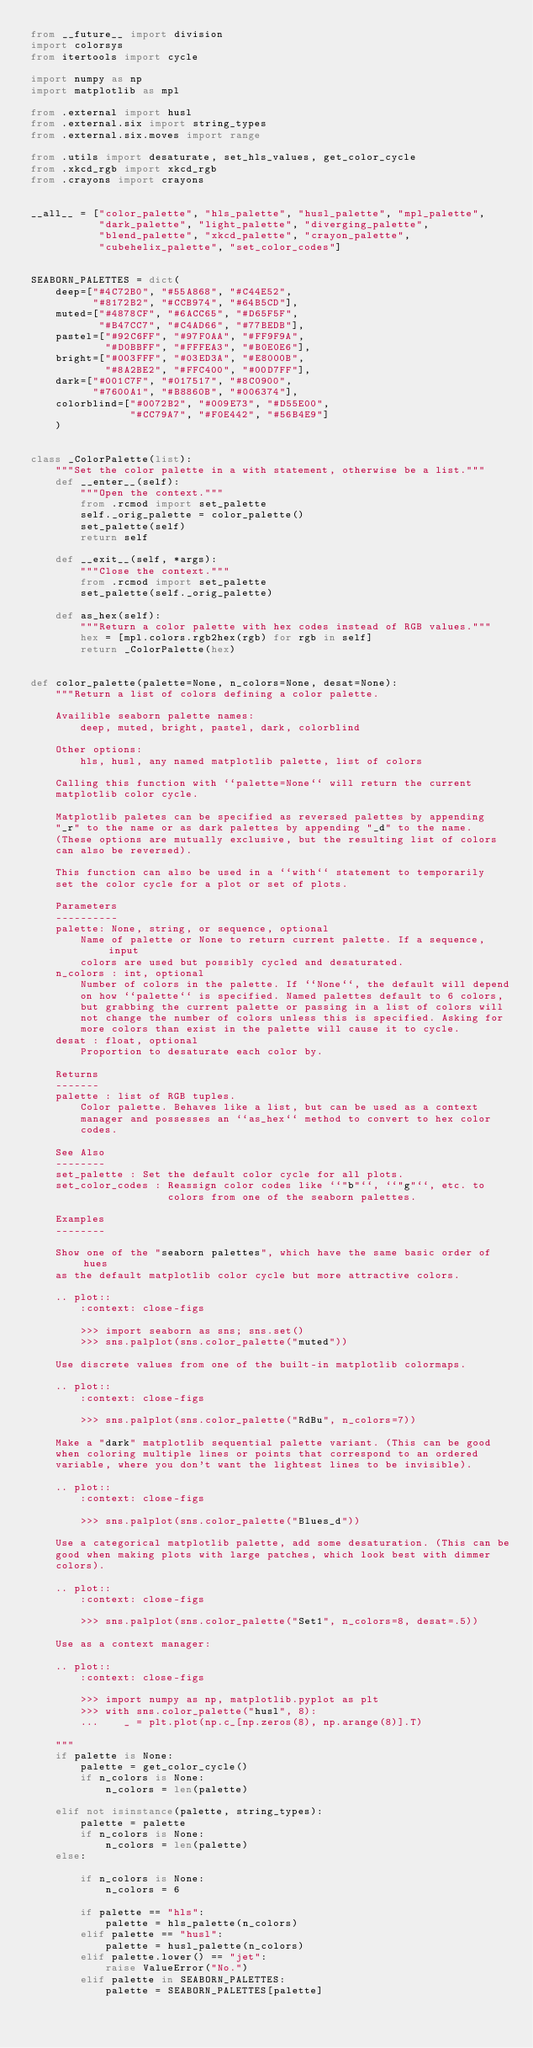Convert code to text. <code><loc_0><loc_0><loc_500><loc_500><_Python_>from __future__ import division
import colorsys
from itertools import cycle

import numpy as np
import matplotlib as mpl

from .external import husl
from .external.six import string_types
from .external.six.moves import range

from .utils import desaturate, set_hls_values, get_color_cycle
from .xkcd_rgb import xkcd_rgb
from .crayons import crayons


__all__ = ["color_palette", "hls_palette", "husl_palette", "mpl_palette",
           "dark_palette", "light_palette", "diverging_palette",
           "blend_palette", "xkcd_palette", "crayon_palette",
           "cubehelix_palette", "set_color_codes"]


SEABORN_PALETTES = dict(
    deep=["#4C72B0", "#55A868", "#C44E52",
          "#8172B2", "#CCB974", "#64B5CD"],
    muted=["#4878CF", "#6ACC65", "#D65F5F",
           "#B47CC7", "#C4AD66", "#77BEDB"],
    pastel=["#92C6FF", "#97F0AA", "#FF9F9A",
            "#D0BBFF", "#FFFEA3", "#B0E0E6"],
    bright=["#003FFF", "#03ED3A", "#E8000B",
            "#8A2BE2", "#FFC400", "#00D7FF"],
    dark=["#001C7F", "#017517", "#8C0900",
          "#7600A1", "#B8860B", "#006374"],
    colorblind=["#0072B2", "#009E73", "#D55E00",
                "#CC79A7", "#F0E442", "#56B4E9"]
    )


class _ColorPalette(list):
    """Set the color palette in a with statement, otherwise be a list."""
    def __enter__(self):
        """Open the context."""
        from .rcmod import set_palette
        self._orig_palette = color_palette()
        set_palette(self)
        return self

    def __exit__(self, *args):
        """Close the context."""
        from .rcmod import set_palette
        set_palette(self._orig_palette)

    def as_hex(self):
        """Return a color palette with hex codes instead of RGB values."""
        hex = [mpl.colors.rgb2hex(rgb) for rgb in self]
        return _ColorPalette(hex)


def color_palette(palette=None, n_colors=None, desat=None):
    """Return a list of colors defining a color palette.

    Availible seaborn palette names:
        deep, muted, bright, pastel, dark, colorblind

    Other options:
        hls, husl, any named matplotlib palette, list of colors

    Calling this function with ``palette=None`` will return the current
    matplotlib color cycle.

    Matplotlib paletes can be specified as reversed palettes by appending
    "_r" to the name or as dark palettes by appending "_d" to the name.
    (These options are mutually exclusive, but the resulting list of colors
    can also be reversed).

    This function can also be used in a ``with`` statement to temporarily
    set the color cycle for a plot or set of plots.

    Parameters
    ----------
    palette: None, string, or sequence, optional
        Name of palette or None to return current palette. If a sequence, input
        colors are used but possibly cycled and desaturated.
    n_colors : int, optional
        Number of colors in the palette. If ``None``, the default will depend
        on how ``palette`` is specified. Named palettes default to 6 colors,
        but grabbing the current palette or passing in a list of colors will
        not change the number of colors unless this is specified. Asking for
        more colors than exist in the palette will cause it to cycle.
    desat : float, optional
        Proportion to desaturate each color by.

    Returns
    -------
    palette : list of RGB tuples.
        Color palette. Behaves like a list, but can be used as a context
        manager and possesses an ``as_hex`` method to convert to hex color
        codes.

    See Also
    --------
    set_palette : Set the default color cycle for all plots.
    set_color_codes : Reassign color codes like ``"b"``, ``"g"``, etc. to
                      colors from one of the seaborn palettes.

    Examples
    --------

    Show one of the "seaborn palettes", which have the same basic order of hues
    as the default matplotlib color cycle but more attractive colors.

    .. plot::
        :context: close-figs

        >>> import seaborn as sns; sns.set()
        >>> sns.palplot(sns.color_palette("muted"))

    Use discrete values from one of the built-in matplotlib colormaps.

    .. plot::
        :context: close-figs

        >>> sns.palplot(sns.color_palette("RdBu", n_colors=7))

    Make a "dark" matplotlib sequential palette variant. (This can be good
    when coloring multiple lines or points that correspond to an ordered
    variable, where you don't want the lightest lines to be invisible).

    .. plot::
        :context: close-figs

        >>> sns.palplot(sns.color_palette("Blues_d"))

    Use a categorical matplotlib palette, add some desaturation. (This can be
    good when making plots with large patches, which look best with dimmer
    colors).

    .. plot::
        :context: close-figs

        >>> sns.palplot(sns.color_palette("Set1", n_colors=8, desat=.5))

    Use as a context manager:

    .. plot::
        :context: close-figs

        >>> import numpy as np, matplotlib.pyplot as plt
        >>> with sns.color_palette("husl", 8):
        ...    _ = plt.plot(np.c_[np.zeros(8), np.arange(8)].T)

    """
    if palette is None:
        palette = get_color_cycle()
        if n_colors is None:
            n_colors = len(palette)

    elif not isinstance(palette, string_types):
        palette = palette
        if n_colors is None:
            n_colors = len(palette)
    else:

        if n_colors is None:
            n_colors = 6

        if palette == "hls":
            palette = hls_palette(n_colors)
        elif palette == "husl":
            palette = husl_palette(n_colors)
        elif palette.lower() == "jet":
            raise ValueError("No.")
        elif palette in SEABORN_PALETTES:
            palette = SEABORN_PALETTES[palette]</code> 